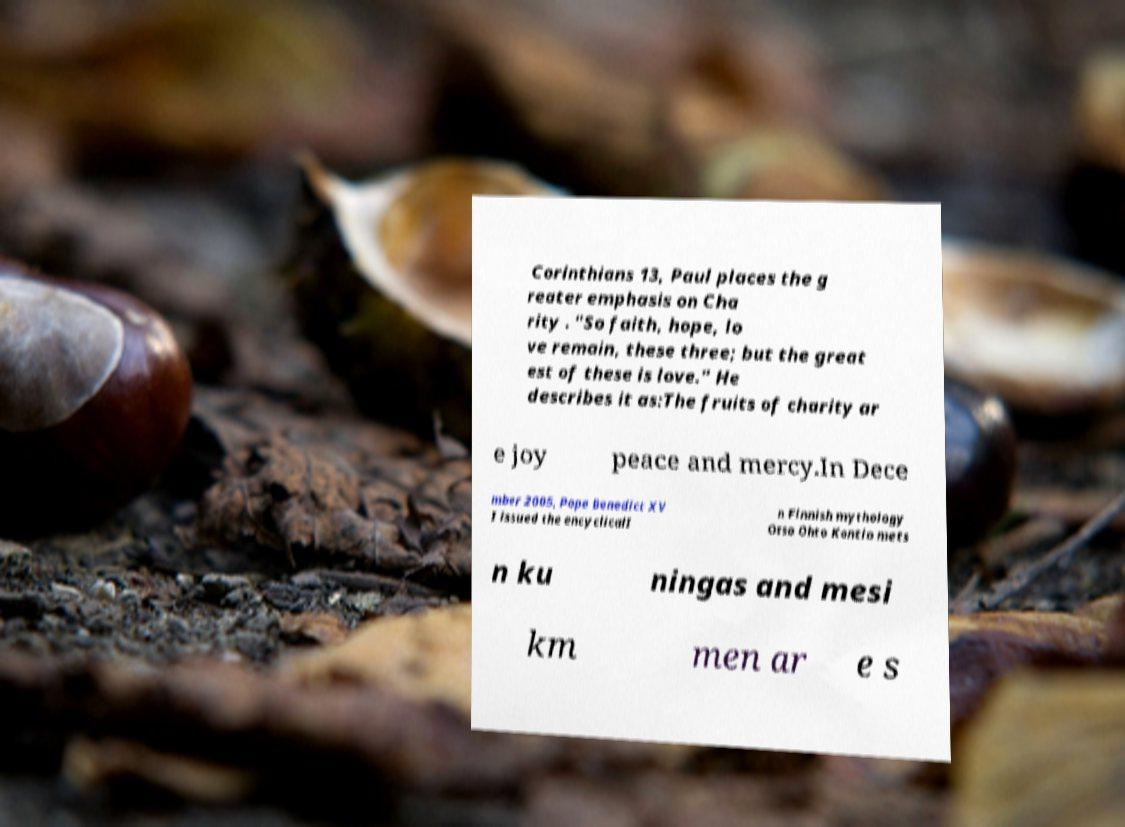Please identify and transcribe the text found in this image. Corinthians 13, Paul places the g reater emphasis on Cha rity . "So faith, hope, lo ve remain, these three; but the great est of these is love." He describes it as:The fruits of charity ar e joy peace and mercy.In Dece mber 2005, Pope Benedict XV I issued the encyclicalI n Finnish mythology Otso Ohto Kontio mets n ku ningas and mesi km men ar e s 